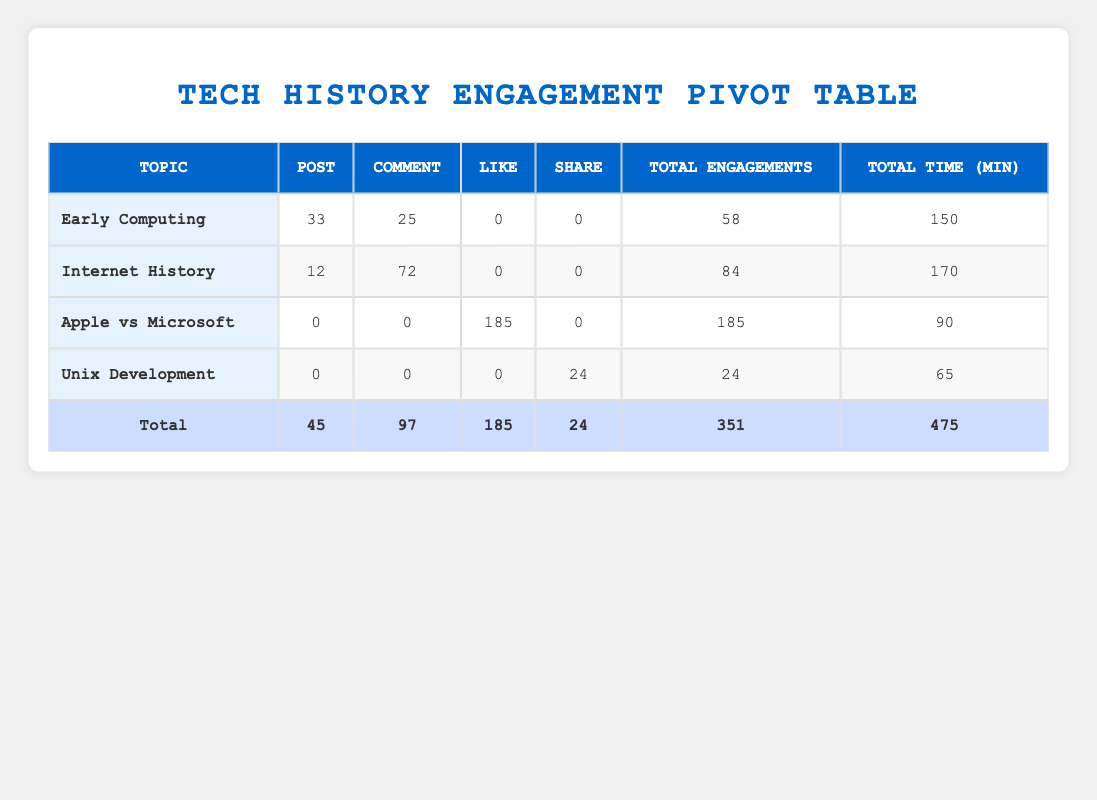What is the total engagement count for the topic "Early Computing"? To find the total engagement count for "Early Computing", look at the table and find the row for this topic. The engagement counts for posts and comments are 33 and 25 respectively. Therefore, total engagements = 33 + 25 = 58.
Answer: 58 Which topic had the highest number of likes? In the table, check the Likes column for each topic. "Apple vs Microsoft" has the highest count of likes at 185.
Answer: Apple vs Microsoft What is the total time spent by users on "Internet History"? The total time spent column for "Internet History" shows 170 minutes. There is no need for further calculations as the value is directly available in the table.
Answer: 170 For which topic is the engagement type 'Share' the highest? Looking through the Share column across all topics, "Unix Development" has 24 engagements from sharing, while other topics have either no shares or less than that.
Answer: Unix Development What is the combined total engagement for "Unix Development" and "Apple vs Microsoft"? First, find the total engagement for each topic: "Unix Development" has 24 total engagements and "Apple vs Microsoft" has 185. Now add them together: 24 + 185 = 209.
Answer: 209 Did any topic have both posts and comments? Refer to the table for each topic. "Internet History" recorded both posts (12) and comments (72), confirming it has both engagement types.
Answer: Yes What is the average time spent per engagement for "Early Computing"? First, identify the total engagements for "Early Computing", which is 58, and the total time spent which is 150 minutes. Now calculate the average: 150 minutes / 58 engagements ≈ 2.59 minutes per engagement.
Answer: 2.59 How many more comments than posts were there for "Internet History"? Check the numbers: "Internet History" has 12 posts and 72 comments. To find the difference, calculate 72 - 12 = 60.
Answer: 60 Which topic had the least total time spent? Review the Total Time column and find the minimum value. "Unix Development" has the least total recorded time of 65 minutes spent.
Answer: Unix Development 